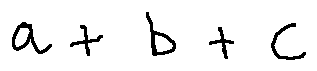Convert formula to latex. <formula><loc_0><loc_0><loc_500><loc_500>a + b + c</formula> 